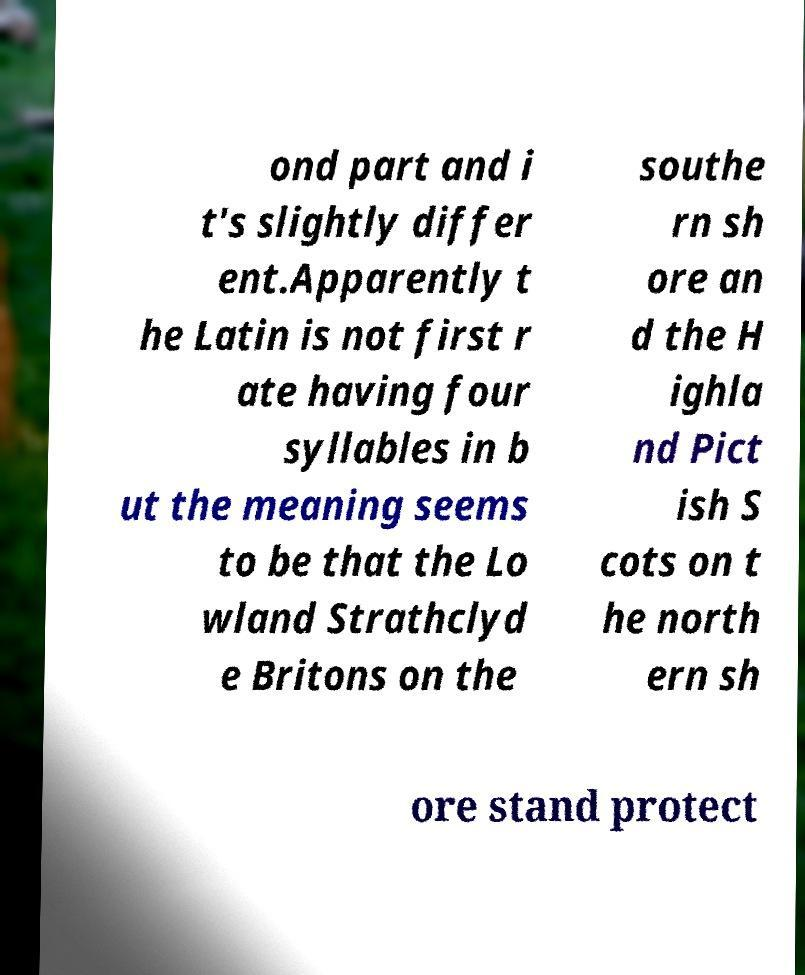Please read and relay the text visible in this image. What does it say? ond part and i t's slightly differ ent.Apparently t he Latin is not first r ate having four syllables in b ut the meaning seems to be that the Lo wland Strathclyd e Britons on the southe rn sh ore an d the H ighla nd Pict ish S cots on t he north ern sh ore stand protect 